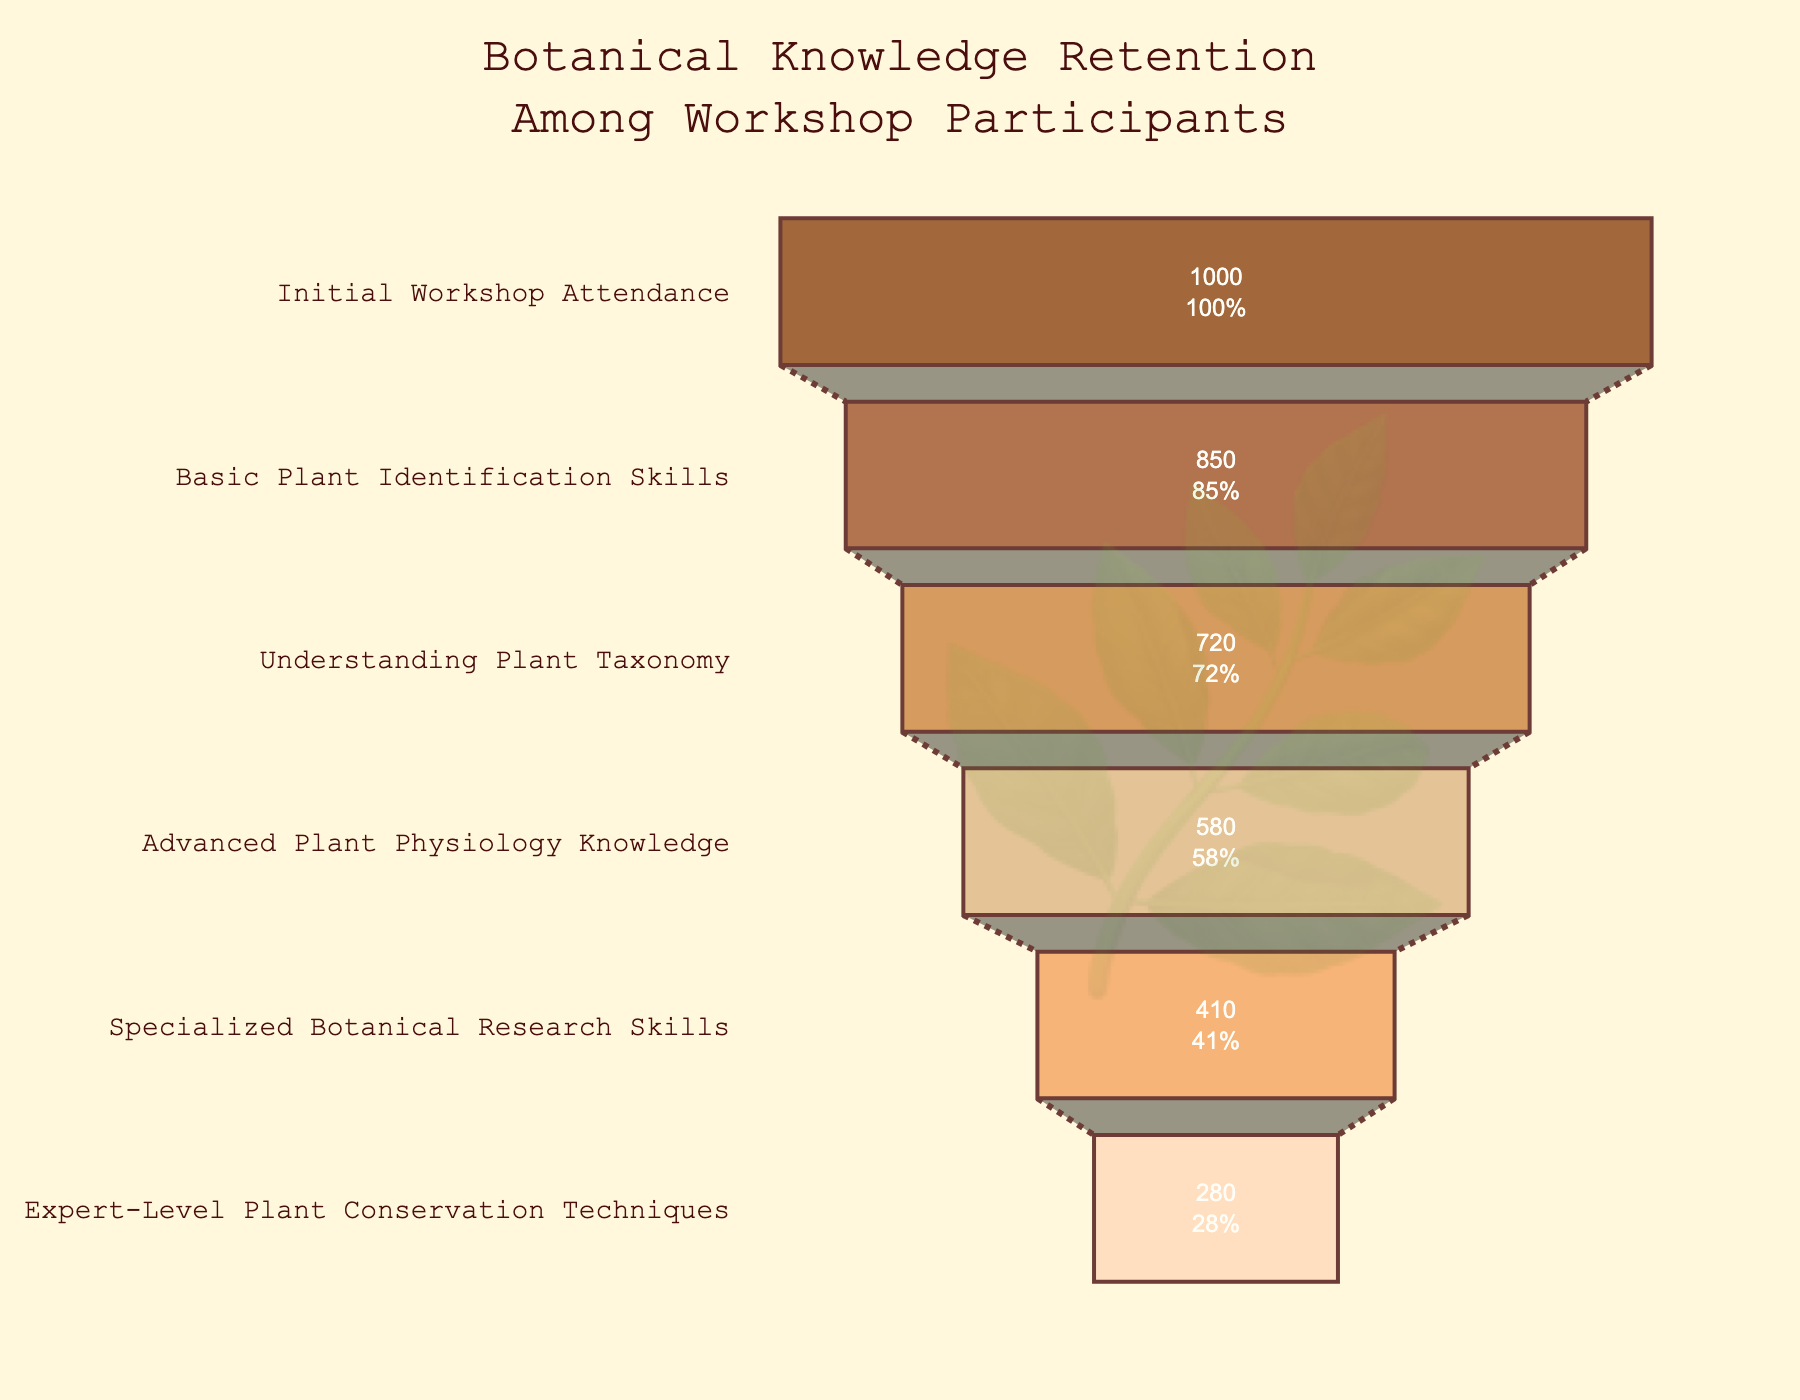How many participants initially attended the workshop? The top section of the funnel chart represents the initial workshop attendance. According to the figure, the number of participants in this stage is shown.
Answer: 1000 How many participants developed Basic Plant Identification Skills? The funnel chart indicates that 850 participants moved from the initial workshop attendance to the Basic Plant Identification Skills stage.
Answer: 850 What percentage of participants progressed to Understanding Plant Taxonomy? Referring to the chart, the stage "Understanding Plant Taxonomy" has 720 participants, and the percentage is shown as 72%.
Answer: 72% What is the drop-off in the number of participants between Understanding Plant Taxonomy and Advanced Plant Physiology Knowledge? The chart shows 720 participants in Understanding Plant Taxonomy and 580 in Advanced Plant Physiology Knowledge. The drop-off is 720 - 580.
Answer: 140 Which stage shows the highest retention rate after the initial workshop attendance? By comparing the percentages, the stage "Basic Plant Identification Skills" has the highest retention rate after the initial attendance.
Answer: Basic Plant Identification Skills What is the cumulative percentage of participants who reached at least Advanced Plant Physiology Knowledge? Sum the percentages of stages up to Advanced Plant Physiology Knowledge: 85% (Basic) + 72% (Taxonomy) + 58% (Physiology)
Answer: 58% How many participants developed Specialized Botanical Research Skills but did not reach Expert-Level Plant Conservation Techniques? The chart shows 410 participants at the Specialized Botanical Research Skills stage and 280 at the Expert-Level Plant Conservation Techniques stage. The difference is 410 - 280.
Answer: 130 Compare the number of participants with Specialized Botanical Research Skills to those with Understanding Plant Taxonomy. The chart shows 410 participants with Specialized Botanical Research Skills and 720 with Understanding Plant Taxonomy. The 410 is less than 720.
Answer: Specialized Botanical Research Skills has fewer participants Which stage has the greatest absolute drop in participants? The drop from one stage to the next is calculated. The largest drop is from Understanding Plant Taxonomy (720) to Advanced Plant Physiology Knowledge (580), a difference of 140 participants.
Answer: Understanding Plant Taxonomy to Advanced Plant Physiology Knowledge If you combine the participants of the first three stages, what is the total number of participants? Add the participants from the Initial Workshop Attendance (1000), Basic Plant Identification Skills (850), and Understanding Plant Taxonomy (720): 1000 + 850 + 720.
Answer: 2570 